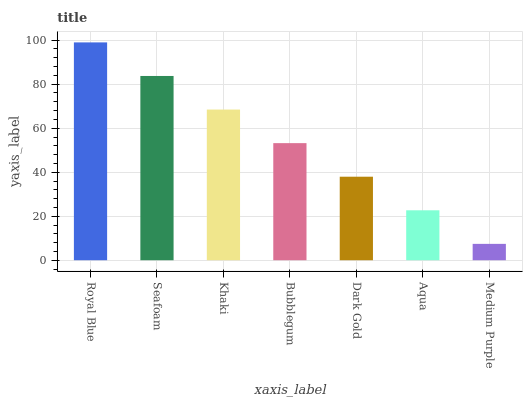Is Medium Purple the minimum?
Answer yes or no. Yes. Is Royal Blue the maximum?
Answer yes or no. Yes. Is Seafoam the minimum?
Answer yes or no. No. Is Seafoam the maximum?
Answer yes or no. No. Is Royal Blue greater than Seafoam?
Answer yes or no. Yes. Is Seafoam less than Royal Blue?
Answer yes or no. Yes. Is Seafoam greater than Royal Blue?
Answer yes or no. No. Is Royal Blue less than Seafoam?
Answer yes or no. No. Is Bubblegum the high median?
Answer yes or no. Yes. Is Bubblegum the low median?
Answer yes or no. Yes. Is Khaki the high median?
Answer yes or no. No. Is Khaki the low median?
Answer yes or no. No. 